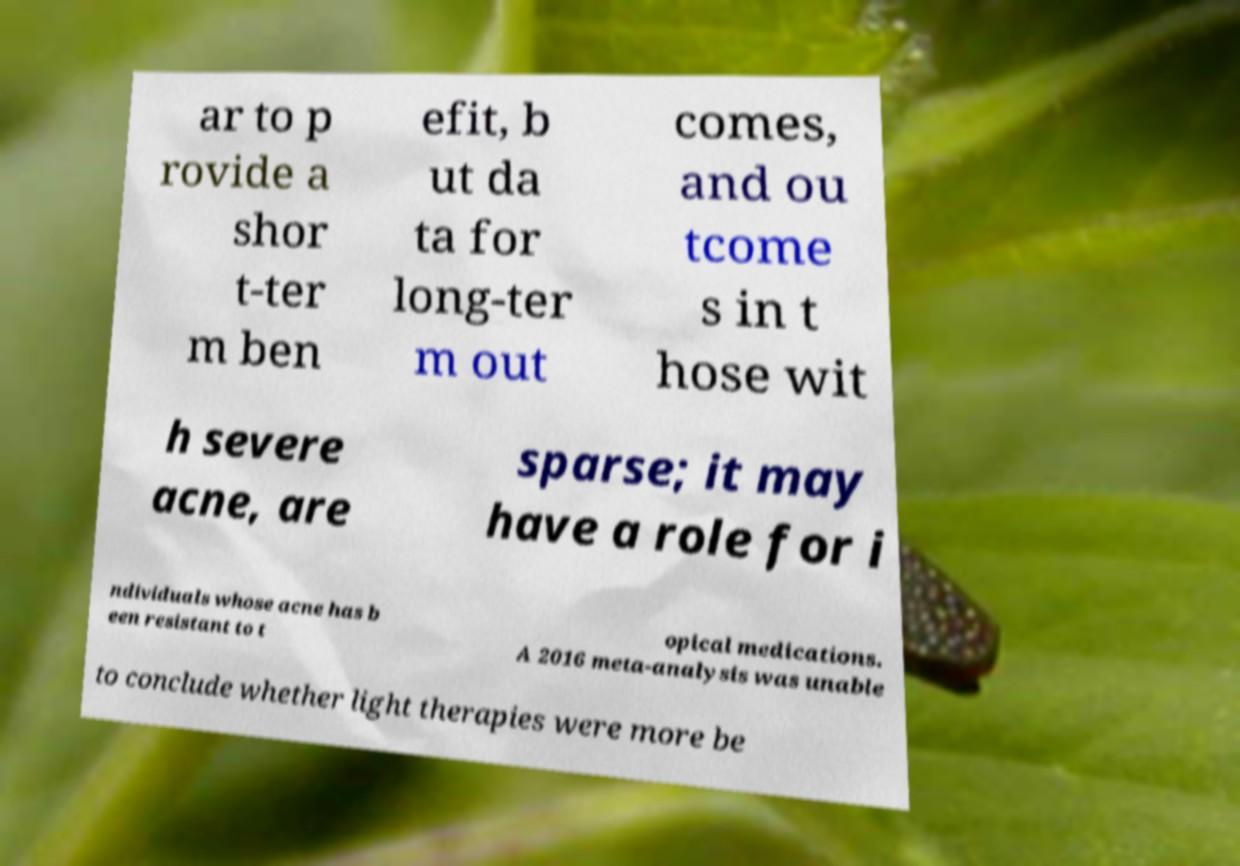I need the written content from this picture converted into text. Can you do that? ar to p rovide a shor t-ter m ben efit, b ut da ta for long-ter m out comes, and ou tcome s in t hose wit h severe acne, are sparse; it may have a role for i ndividuals whose acne has b een resistant to t opical medications. A 2016 meta-analysis was unable to conclude whether light therapies were more be 